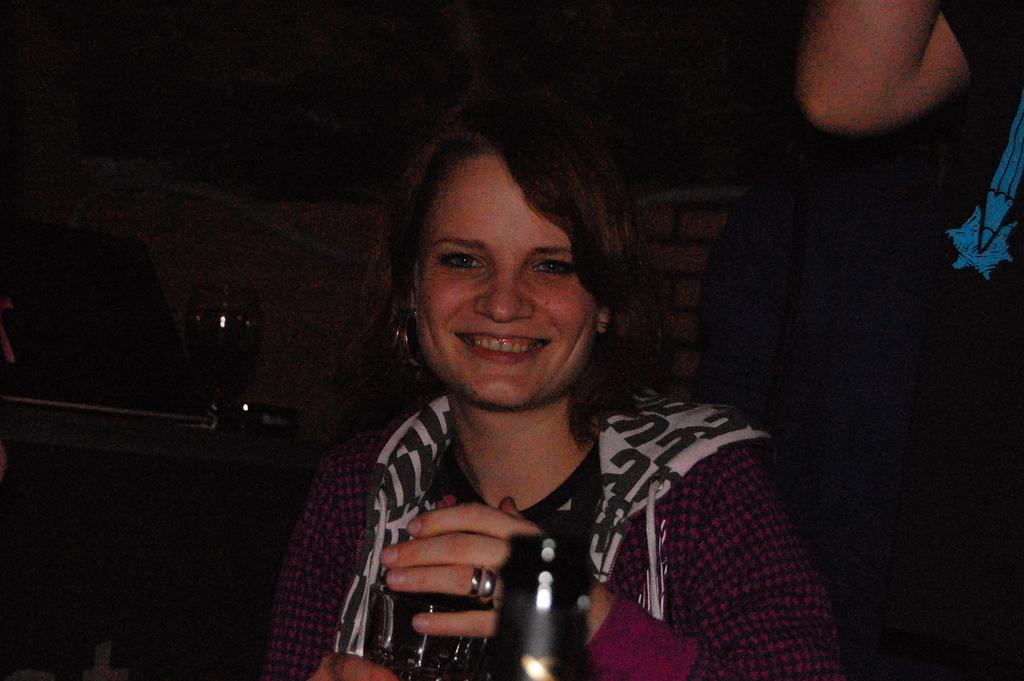Who is present in the image? There is a woman and a person standing in the image. What is the woman doing in the image? The woman is smiling in the image. What objects can be seen in the image? There is a bottle and a glass in the image. What can be said about the background of the image? The background of the image is dark. What type of government is depicted in the image? There is no depiction of a government in the image; it features a woman, a person standing, a bottle, a glass, and a dark background. What liquid is being poured from the bottle into the glass in the image? There is no liquid being poured in the image; it only shows a bottle and a glass. 